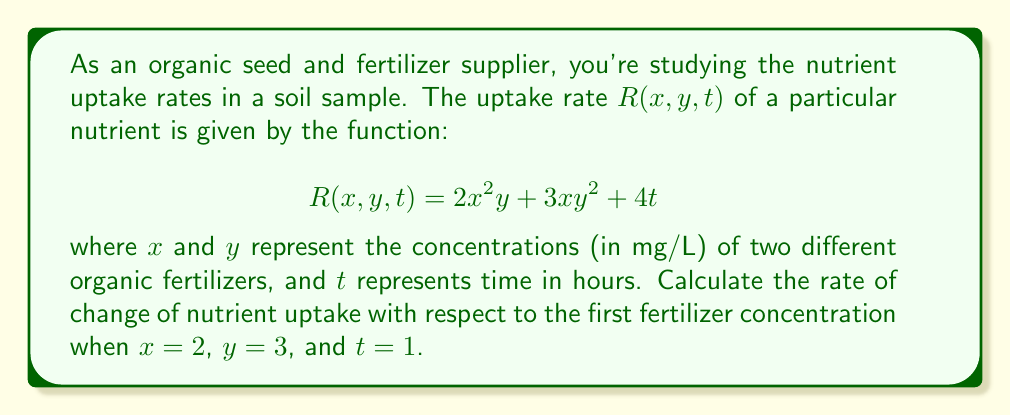Show me your answer to this math problem. To solve this problem, we need to use partial differentiation, a concept from multivariable calculus. Here's the step-by-step solution:

1) The rate of change of nutrient uptake with respect to the first fertilizer concentration (x) is given by the partial derivative $\frac{\partial R}{\partial x}$.

2) To find $\frac{\partial R}{\partial x}$, we differentiate $R$ with respect to $x$, treating $y$ and $t$ as constants:

   $$\frac{\partial R}{\partial x} = \frac{\partial}{\partial x}(2x^2y + 3xy^2 + 4t)$$

3) Applying the differentiation rules:
   
   $$\frac{\partial R}{\partial x} = 4xy + 3y^2$$

4) Now, we need to evaluate this at the given point $(x=2, y=3, t=1)$:

   $$\frac{\partial R}{\partial x}\bigg|_{(2,3,1)} = 4(2)(3) + 3(3^2)$$

5) Simplifying:

   $$\frac{\partial R}{\partial x}\bigg|_{(2,3,1)} = 24 + 27 = 51$$

Therefore, the rate of change of nutrient uptake with respect to the first fertilizer concentration at the given point is 51 mg/L per unit change in x.
Answer: 51 mg/L per unit change in x 